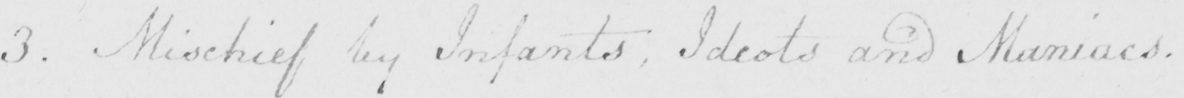Transcribe the text shown in this historical manuscript line. 3 . Mischief by Infants , Idiots and Maniacs . 